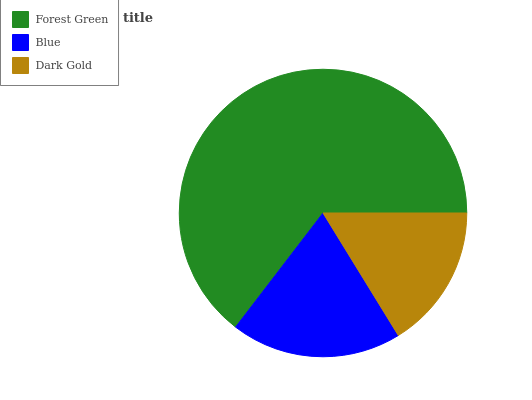Is Dark Gold the minimum?
Answer yes or no. Yes. Is Forest Green the maximum?
Answer yes or no. Yes. Is Blue the minimum?
Answer yes or no. No. Is Blue the maximum?
Answer yes or no. No. Is Forest Green greater than Blue?
Answer yes or no. Yes. Is Blue less than Forest Green?
Answer yes or no. Yes. Is Blue greater than Forest Green?
Answer yes or no. No. Is Forest Green less than Blue?
Answer yes or no. No. Is Blue the high median?
Answer yes or no. Yes. Is Blue the low median?
Answer yes or no. Yes. Is Dark Gold the high median?
Answer yes or no. No. Is Dark Gold the low median?
Answer yes or no. No. 